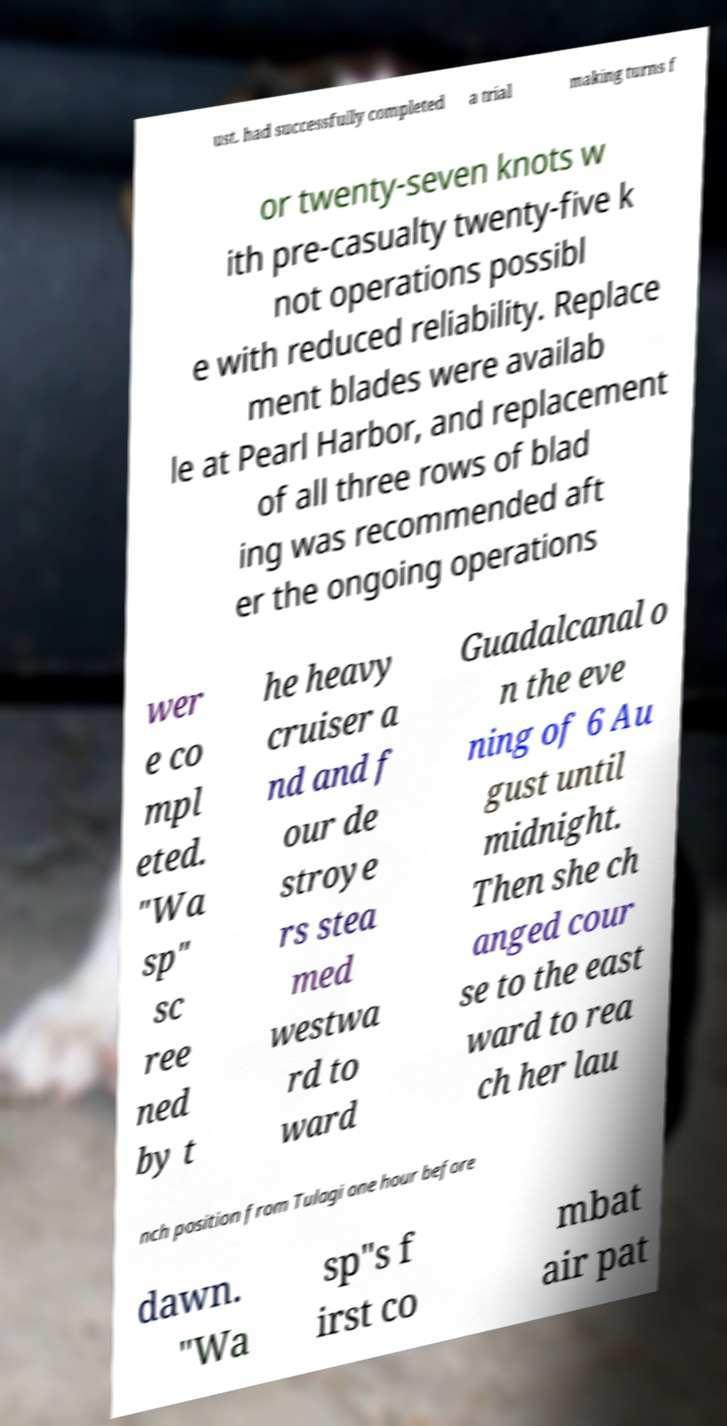Can you read and provide the text displayed in the image?This photo seems to have some interesting text. Can you extract and type it out for me? ust. had successfully completed a trial making turns f or twenty-seven knots w ith pre-casualty twenty-five k not operations possibl e with reduced reliability. Replace ment blades were availab le at Pearl Harbor, and replacement of all three rows of blad ing was recommended aft er the ongoing operations wer e co mpl eted. "Wa sp" sc ree ned by t he heavy cruiser a nd and f our de stroye rs stea med westwa rd to ward Guadalcanal o n the eve ning of 6 Au gust until midnight. Then she ch anged cour se to the east ward to rea ch her lau nch position from Tulagi one hour before dawn. "Wa sp"s f irst co mbat air pat 